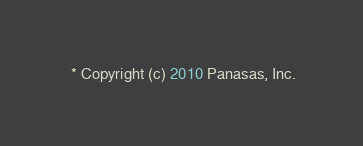Convert code to text. <code><loc_0><loc_0><loc_500><loc_500><_C_> * Copyright (c) 2010 Panasas, Inc.</code> 